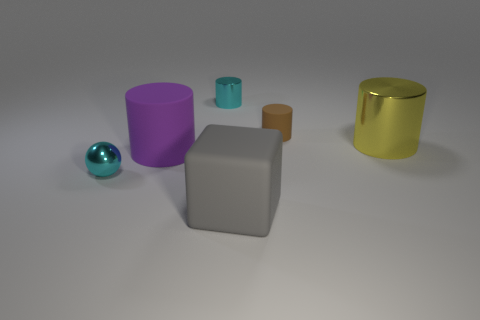How many green objects are tiny metal cylinders or small cylinders?
Keep it short and to the point. 0. Is the material of the tiny cyan cylinder the same as the large gray object?
Give a very brief answer. No. What number of tiny shiny spheres are on the left side of the large purple thing?
Provide a short and direct response. 1. What material is the object that is both in front of the big purple matte cylinder and on the right side of the large purple cylinder?
Give a very brief answer. Rubber. How many cylinders are either purple rubber objects or big metallic things?
Your response must be concise. 2. What material is the tiny brown thing that is the same shape as the large yellow metallic object?
Your answer should be very brief. Rubber. The cyan thing that is the same material as the cyan cylinder is what size?
Your answer should be very brief. Small. Do the tiny cyan metallic thing on the right side of the shiny sphere and the matte object in front of the big purple cylinder have the same shape?
Give a very brief answer. No. What color is the tiny thing that is the same material as the large gray object?
Your answer should be very brief. Brown. There is a metallic thing behind the big yellow cylinder; is its size the same as the shiny thing in front of the purple thing?
Make the answer very short. Yes. 